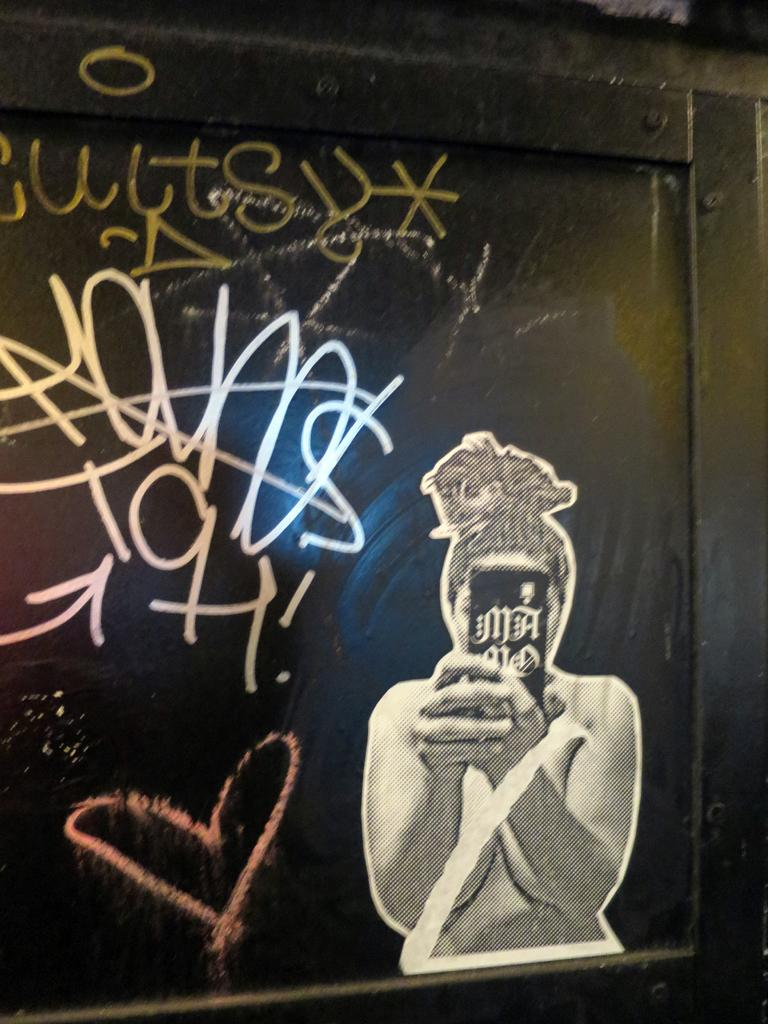What is the main subject in the image? There is a poster in the image. How many different selections of flooring can be seen in the image? There is no flooring visible in the image, as it only features a poster. 